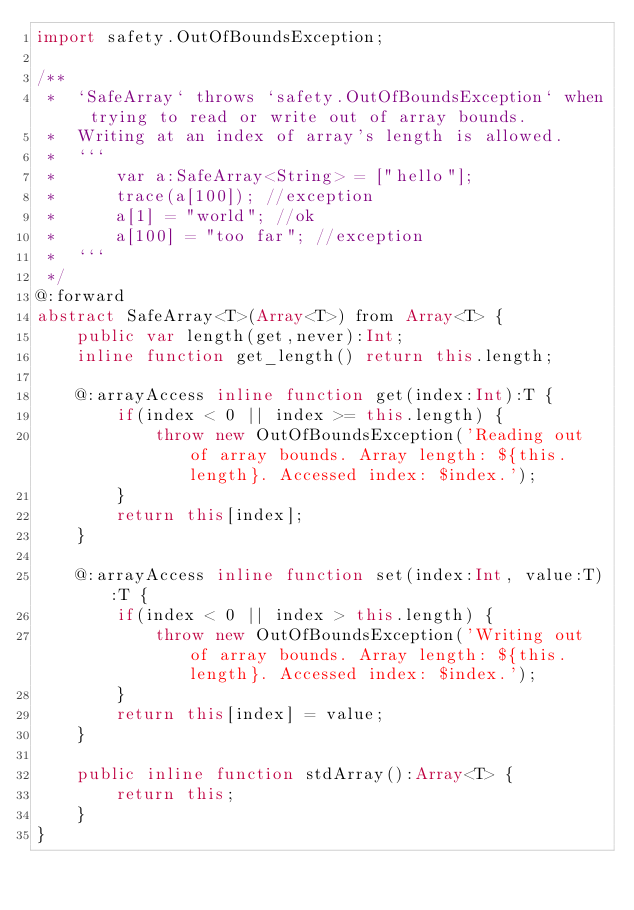<code> <loc_0><loc_0><loc_500><loc_500><_Haxe_>import safety.OutOfBoundsException;

/**
 *  `SafeArray` throws `safety.OutOfBoundsException` when trying to read or write out of array bounds.
 *  Writing at an index of array's length is allowed.
 *  ```
 *  	var a:SafeArray<String> = ["hello"];
 *  	trace(a[100]); //exception
 *  	a[1] = "world"; //ok
 *  	a[100] = "too far"; //exception
 *  ```
 */
@:forward
abstract SafeArray<T>(Array<T>) from Array<T> {
	public var length(get,never):Int;
	inline function get_length() return this.length;

	@:arrayAccess inline function get(index:Int):T {
		if(index < 0 || index >= this.length) {
			throw new OutOfBoundsException('Reading out of array bounds. Array length: ${this.length}. Accessed index: $index.');
		}
		return this[index];
	}

	@:arrayAccess inline function set(index:Int, value:T):T {
		if(index < 0 || index > this.length) {
			throw new OutOfBoundsException('Writing out of array bounds. Array length: ${this.length}. Accessed index: $index.');
		}
		return this[index] = value;
	}

	public inline function stdArray():Array<T> {
		return this;
	}
}</code> 